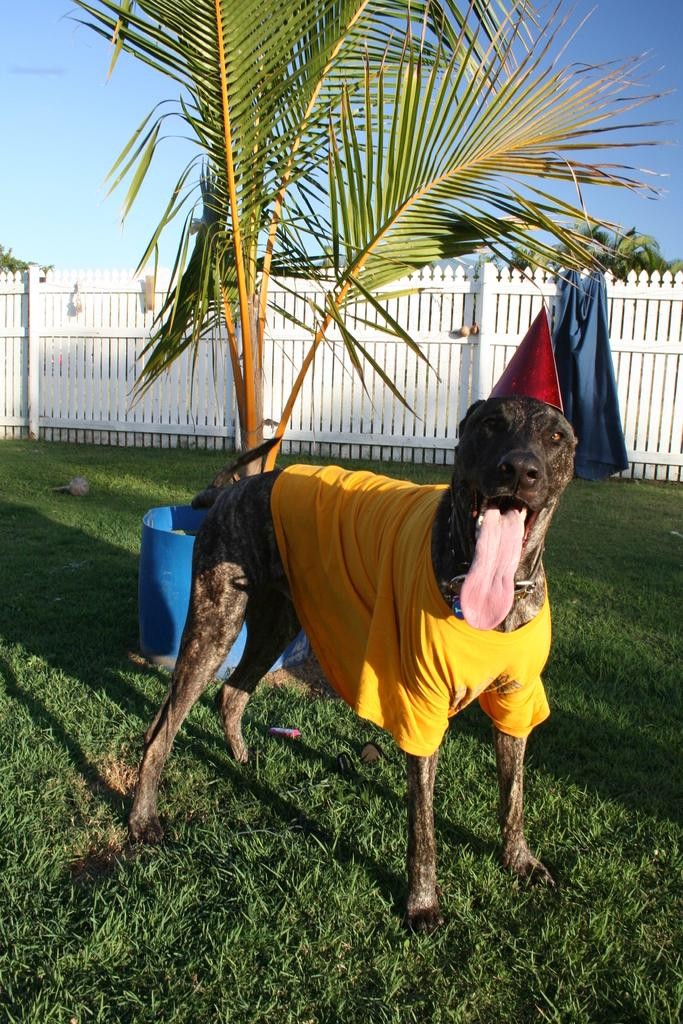What type of animal is in the image? There is a dog in the image. What is the dog wearing? The dog is wearing a cap. What can be seen in the background of the image? There are trees and the sky visible in the background of the image. What is the dog's location in relation to the fence? The fence is in the image, but the dog's specific location relative to the fence is not clear. What is present on the ground in the image? Clothes and other objects are present on the ground in the image. What type of account does the dog have in the image? There is no mention of an account in the image, as it features a dog wearing a cap, trees, a fence, and objects on the ground. How many cars are visible in the image? There are no cars present in the image. 